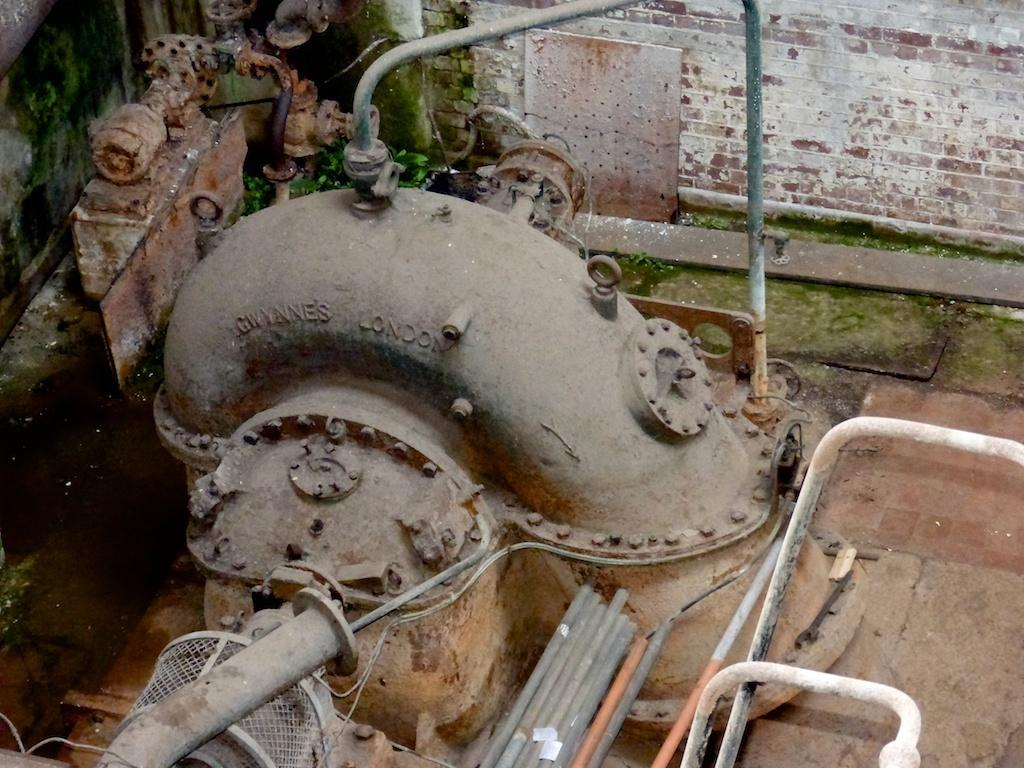What can be seen in the background of the image? There is a wall in the background of the image. What type of natural growth is present in the image? There is the formation of algae in the image. What man-made structures are visible in the image? There are pipes visible in the image. How many objects can be identified in the image? There are a few objects in the image. What type of string is used to hold the algae in the image? There is no string present in the image; the algae is naturally formed and not held by any string. 